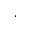Convert formula to latex. <formula><loc_0><loc_0><loc_500><loc_500>\cdot</formula> 